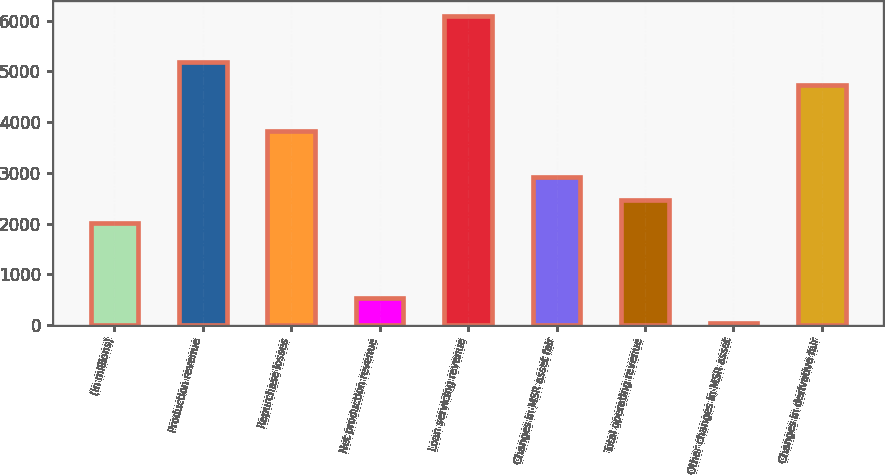<chart> <loc_0><loc_0><loc_500><loc_500><bar_chart><fcel>(in millions)<fcel>Production revenue<fcel>Repurchase losses<fcel>Net production revenue<fcel>Loan servicing revenue<fcel>Changes in MSR asset fair<fcel>Total operating revenue<fcel>Other changes in MSR asset<fcel>Changes in derivative fair<nl><fcel>2010<fcel>5181.7<fcel>3822.4<fcel>528<fcel>6087.9<fcel>2916.2<fcel>2463.1<fcel>44<fcel>4728.6<nl></chart> 